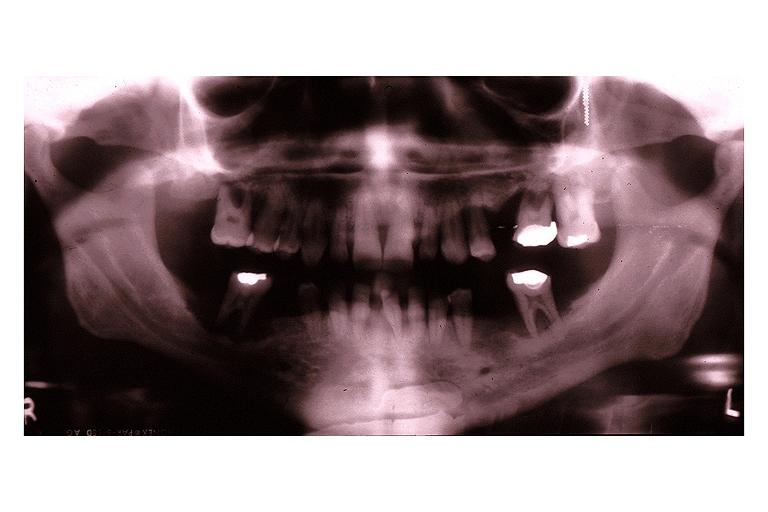does this image show langerhans cell histiocytosis eosinophilic granuloma?
Answer the question using a single word or phrase. Yes 